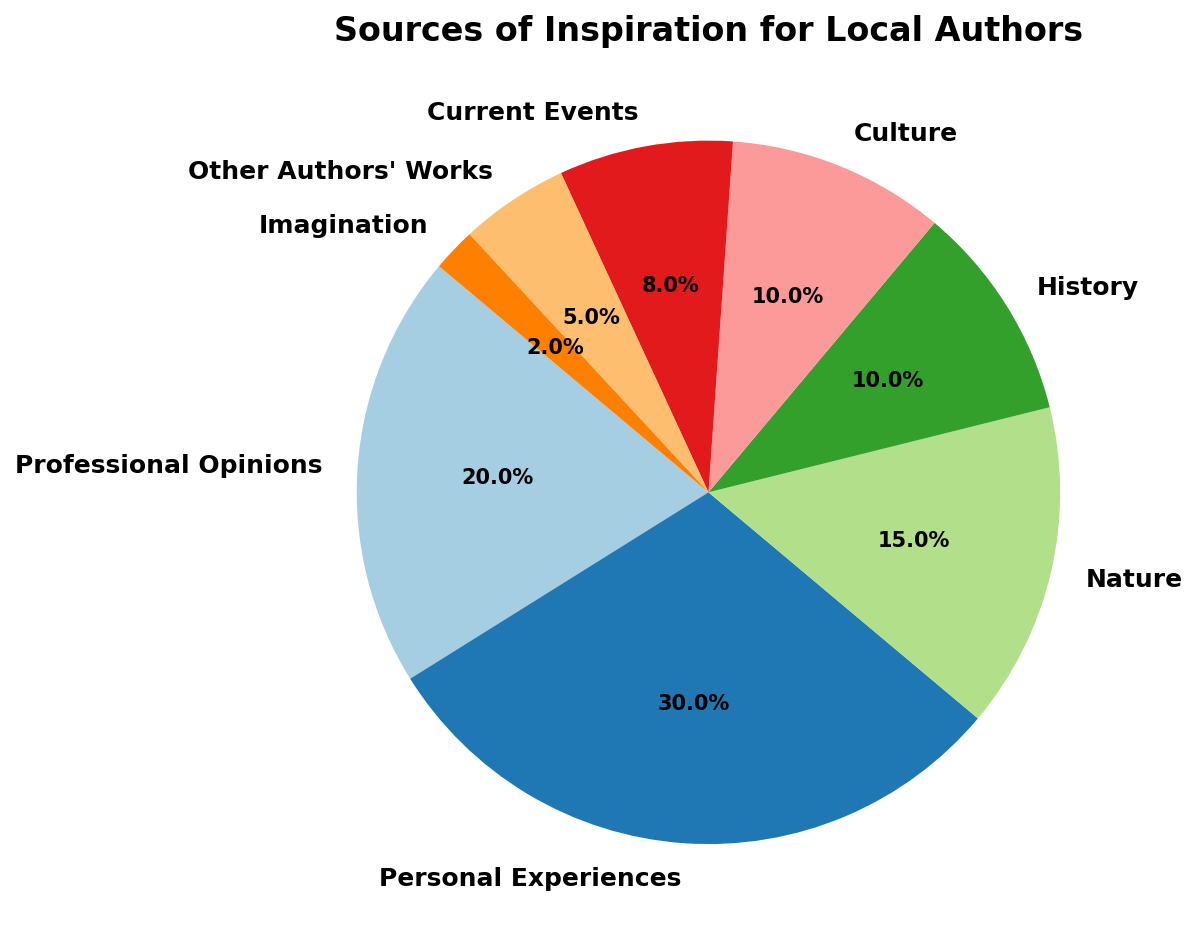What's the most common source of inspiration for local authors? The figure shows that the largest wedge of the pie chart corresponds to "Personal Experiences" with a percentage of 30%, making it the most common source of inspiration.
Answer: Personal Experiences Which two sources of inspiration together make up 30% of the authors' inspirations? According to the pie chart, "Professional Opinions" account for 20% and "Nature" accounts for 15%. The combined sum of these two sources exceeds 30%, so we look for two smaller sources whose percentages add up to 30%. "History" and "Culture" each account for 10%, and "Current Events" accounts for 8%. Hence, "History" (10%) and "Culture" (10%) together with "Current Events" (8%) will be 28%—we need to adjust by combining sources slightly differently. Finally, "Professional Opinions" (20%) and "Current Events" (8%) together sum up to 28%, not 30%. Since the exact pairs to sum to 30% isn’t directly obvious, the closest combination would be "History" and "Culture."
Answer: History, Culture How does the percentage of authors inspired by Nature compare to those inspired by History? Direct comparison shows that the percentage of authors inspired by "Nature" is 15%, while those inspired by "History" is 10%. 15% is greater than 10%.
Answer: Nature is greater Which source of inspiration has the smallest representation, and what is its percentage? The segment labeled "Imagination" is the smallest wedge in the pie chart, representing just 2% of the authors' inspirations.
Answer: Imagination, 2% What is the combined percentage of authors inspired by Professional Opinions, Nature, and History? Summing up the percentages for "Professional Opinions" (20%), "Nature" (15%), and "History" (10%) gives 20% + 15% + 10% = 45%.
Answer: 45% If you were to combine the percentages of "Personal Experiences" and "Nature", how much more is it compared to "Professional Opinions"? "Personal Experiences" accounts for 30% and "Nature" for 15%. Combined, they sum to 45%. Subtracting "Professional Opinions" (20%) from this total yields 45% - 20% = 25%.
Answer: 25% In the pie chart, which source is represented by the color directly to the right of the "Professional Opinions" segment? The "Professional Opinions" slice starts at a specific angle and the next slice to the right is "Personal Experiences".
Answer: Personal Experiences Rank the sources of inspiration in descending order. Ranking the sources based on their percentages as depicted in the pie chart: 1. Personal Experiences (30%), 2. Professional Opinions (20%), 3. Nature (15%), 4. History (10%), 5. Culture (10%), 6. Current Events (8%), 7. Other Authors' Works (5%), 8. Imagination (2%).
Answer: Personal Experiences, Professional Opinions, Nature, History, Culture, Current Events, Other Authors' Works, Imagination What is the difference in percentage points between the sources of inspiration from "Other Authors' Works" and "Imagination"? The percentages for "Other Authors' Works" and "Imagination" are 5% and 2% respectively. The difference is calculated by 5% - 2% = 3%.
Answer: 3% 